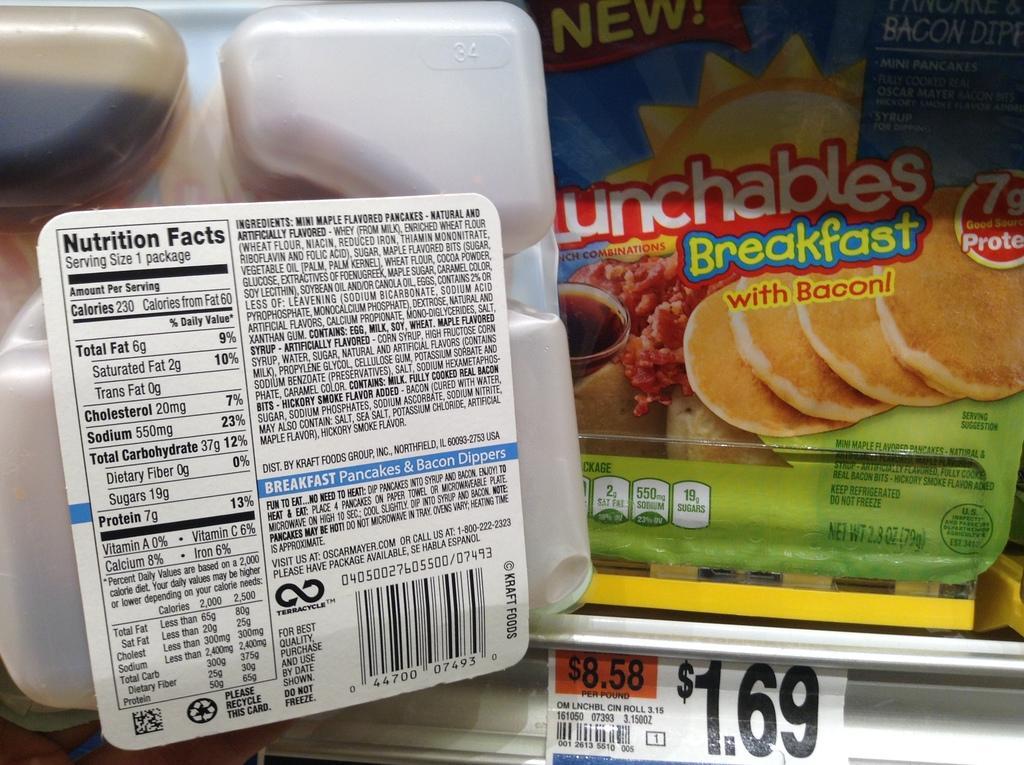Could you give a brief overview of what you see in this image? In this image we can see food packets and a price tag. 